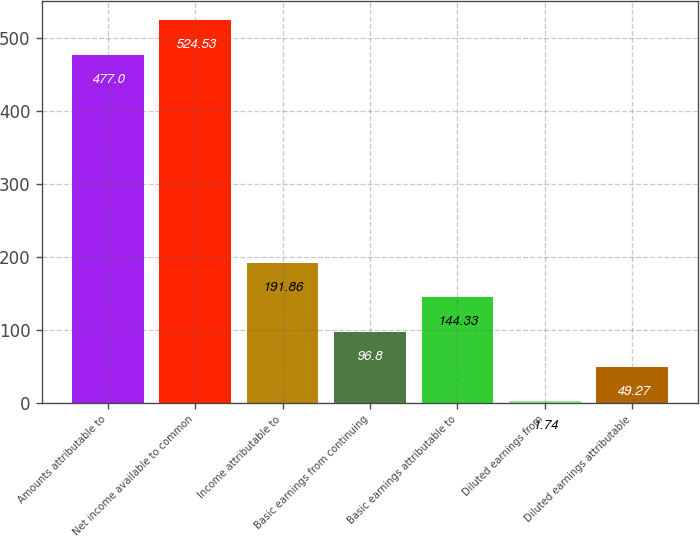<chart> <loc_0><loc_0><loc_500><loc_500><bar_chart><fcel>Amounts attributable to<fcel>Net income available to common<fcel>Income attributable to<fcel>Basic earnings from continuing<fcel>Basic earnings attributable to<fcel>Diluted earnings from<fcel>Diluted earnings attributable<nl><fcel>477<fcel>524.53<fcel>191.86<fcel>96.8<fcel>144.33<fcel>1.74<fcel>49.27<nl></chart> 